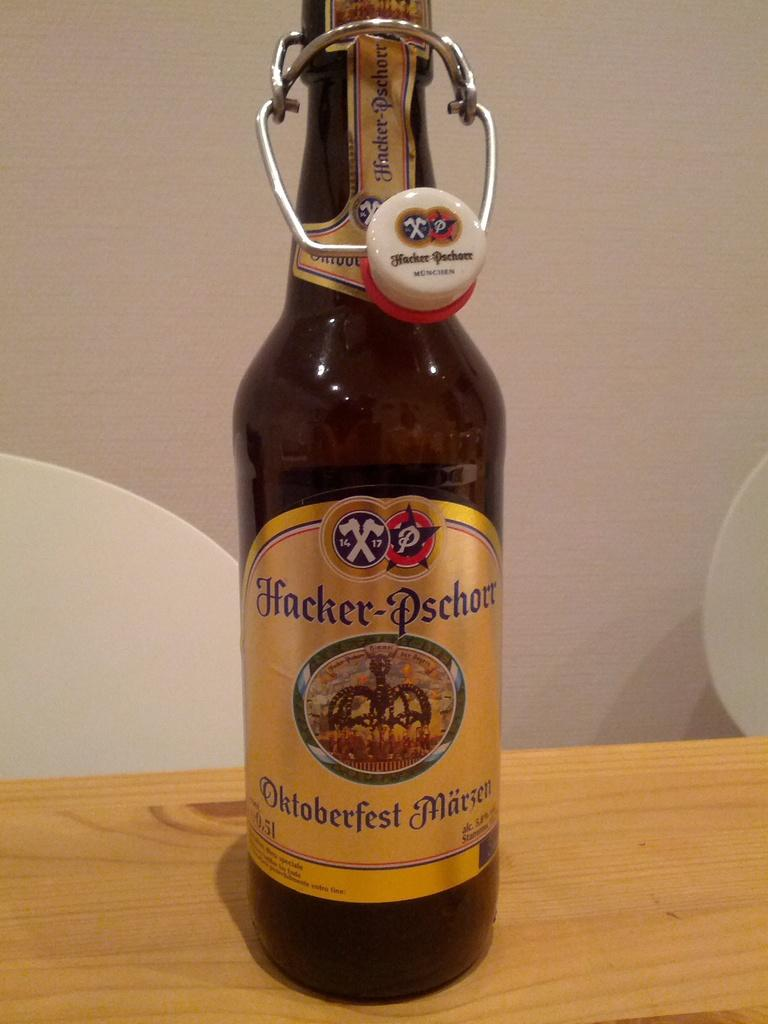<image>
Give a short and clear explanation of the subsequent image. A bottle of Hacker-Pschorr Oktoberfest beer sits on a wooden table. 